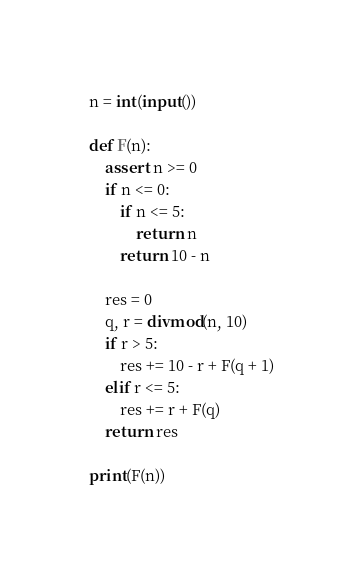Convert code to text. <code><loc_0><loc_0><loc_500><loc_500><_Python_>
n = int(input())

def F(n):
    assert n >= 0
    if n <= 0:
        if n <= 5:
            return n
        return 10 - n
    
    res = 0
    q, r = divmod(n, 10)
    if r > 5:
        res += 10 - r + F(q + 1)
    elif r <= 5:
        res += r + F(q)
    return res

print(F(n))</code> 